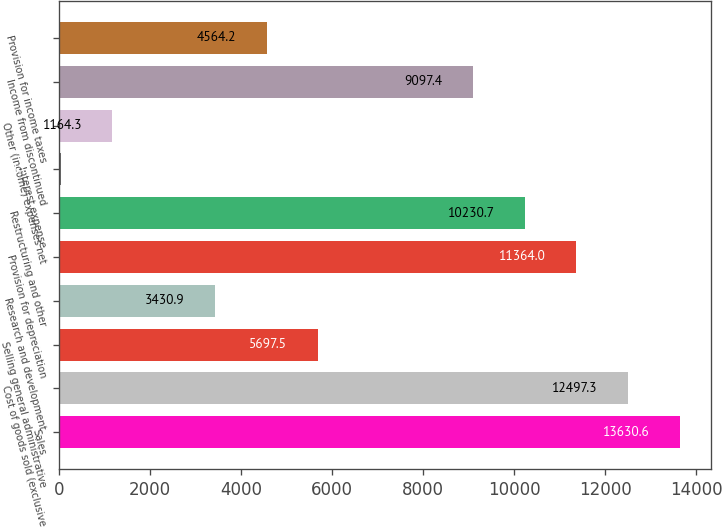Convert chart to OTSL. <chart><loc_0><loc_0><loc_500><loc_500><bar_chart><fcel>Sales<fcel>Cost of goods sold (exclusive<fcel>Selling general administrative<fcel>Research and development<fcel>Provision for depreciation<fcel>Restructuring and other<fcel>Interest expense<fcel>Other (income) expenses net<fcel>Income from discontinued<fcel>Provision for income taxes<nl><fcel>13630.6<fcel>12497.3<fcel>5697.5<fcel>3430.9<fcel>11364<fcel>10230.7<fcel>31<fcel>1164.3<fcel>9097.4<fcel>4564.2<nl></chart> 